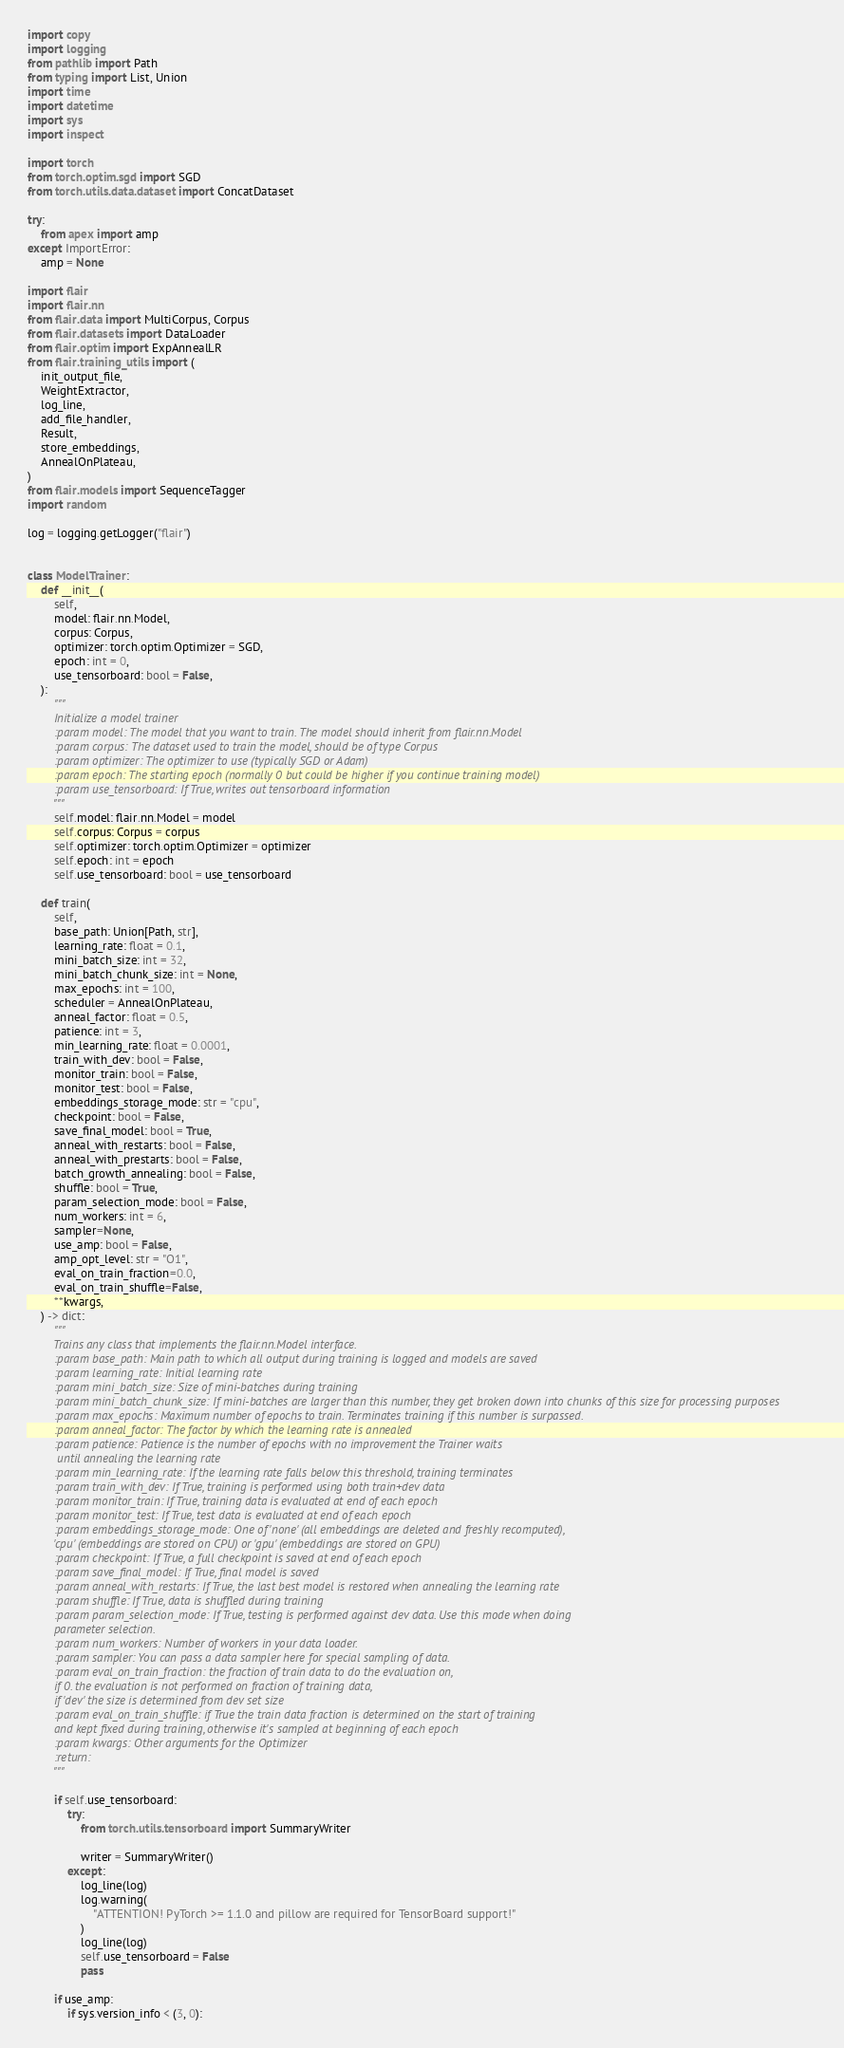Convert code to text. <code><loc_0><loc_0><loc_500><loc_500><_Python_>import copy
import logging
from pathlib import Path
from typing import List, Union
import time
import datetime
import sys
import inspect

import torch
from torch.optim.sgd import SGD
from torch.utils.data.dataset import ConcatDataset

try:
    from apex import amp
except ImportError:
    amp = None

import flair
import flair.nn
from flair.data import MultiCorpus, Corpus
from flair.datasets import DataLoader
from flair.optim import ExpAnnealLR
from flair.training_utils import (
    init_output_file,
    WeightExtractor,
    log_line,
    add_file_handler,
    Result,
    store_embeddings,
    AnnealOnPlateau,
)
from flair.models import SequenceTagger
import random

log = logging.getLogger("flair")


class ModelTrainer:
    def __init__(
        self,
        model: flair.nn.Model,
        corpus: Corpus,
        optimizer: torch.optim.Optimizer = SGD,
        epoch: int = 0,
        use_tensorboard: bool = False,
    ):
        """
        Initialize a model trainer
        :param model: The model that you want to train. The model should inherit from flair.nn.Model
        :param corpus: The dataset used to train the model, should be of type Corpus
        :param optimizer: The optimizer to use (typically SGD or Adam)
        :param epoch: The starting epoch (normally 0 but could be higher if you continue training model)
        :param use_tensorboard: If True, writes out tensorboard information
        """
        self.model: flair.nn.Model = model
        self.corpus: Corpus = corpus
        self.optimizer: torch.optim.Optimizer = optimizer
        self.epoch: int = epoch
        self.use_tensorboard: bool = use_tensorboard

    def train(
        self,
        base_path: Union[Path, str],
        learning_rate: float = 0.1,
        mini_batch_size: int = 32,
        mini_batch_chunk_size: int = None,
        max_epochs: int = 100,
        scheduler = AnnealOnPlateau,
        anneal_factor: float = 0.5,
        patience: int = 3,
        min_learning_rate: float = 0.0001,
        train_with_dev: bool = False,
        monitor_train: bool = False,
        monitor_test: bool = False,
        embeddings_storage_mode: str = "cpu",
        checkpoint: bool = False,
        save_final_model: bool = True,
        anneal_with_restarts: bool = False,
        anneal_with_prestarts: bool = False,
        batch_growth_annealing: bool = False,
        shuffle: bool = True,
        param_selection_mode: bool = False,
        num_workers: int = 6,
        sampler=None,
        use_amp: bool = False,
        amp_opt_level: str = "O1",
        eval_on_train_fraction=0.0,
        eval_on_train_shuffle=False,
        **kwargs,
    ) -> dict:
        """
        Trains any class that implements the flair.nn.Model interface.
        :param base_path: Main path to which all output during training is logged and models are saved
        :param learning_rate: Initial learning rate
        :param mini_batch_size: Size of mini-batches during training
        :param mini_batch_chunk_size: If mini-batches are larger than this number, they get broken down into chunks of this size for processing purposes
        :param max_epochs: Maximum number of epochs to train. Terminates training if this number is surpassed.
        :param anneal_factor: The factor by which the learning rate is annealed
        :param patience: Patience is the number of epochs with no improvement the Trainer waits
         until annealing the learning rate
        :param min_learning_rate: If the learning rate falls below this threshold, training terminates
        :param train_with_dev: If True, training is performed using both train+dev data
        :param monitor_train: If True, training data is evaluated at end of each epoch
        :param monitor_test: If True, test data is evaluated at end of each epoch
        :param embeddings_storage_mode: One of 'none' (all embeddings are deleted and freshly recomputed),
        'cpu' (embeddings are stored on CPU) or 'gpu' (embeddings are stored on GPU)
        :param checkpoint: If True, a full checkpoint is saved at end of each epoch
        :param save_final_model: If True, final model is saved
        :param anneal_with_restarts: If True, the last best model is restored when annealing the learning rate
        :param shuffle: If True, data is shuffled during training
        :param param_selection_mode: If True, testing is performed against dev data. Use this mode when doing
        parameter selection.
        :param num_workers: Number of workers in your data loader.
        :param sampler: You can pass a data sampler here for special sampling of data.
        :param eval_on_train_fraction: the fraction of train data to do the evaluation on,
        if 0. the evaluation is not performed on fraction of training data,
        if 'dev' the size is determined from dev set size
        :param eval_on_train_shuffle: if True the train data fraction is determined on the start of training
        and kept fixed during training, otherwise it's sampled at beginning of each epoch
        :param kwargs: Other arguments for the Optimizer
        :return:
        """

        if self.use_tensorboard:
            try:
                from torch.utils.tensorboard import SummaryWriter

                writer = SummaryWriter()
            except:
                log_line(log)
                log.warning(
                    "ATTENTION! PyTorch >= 1.1.0 and pillow are required for TensorBoard support!"
                )
                log_line(log)
                self.use_tensorboard = False
                pass

        if use_amp:
            if sys.version_info < (3, 0):</code> 